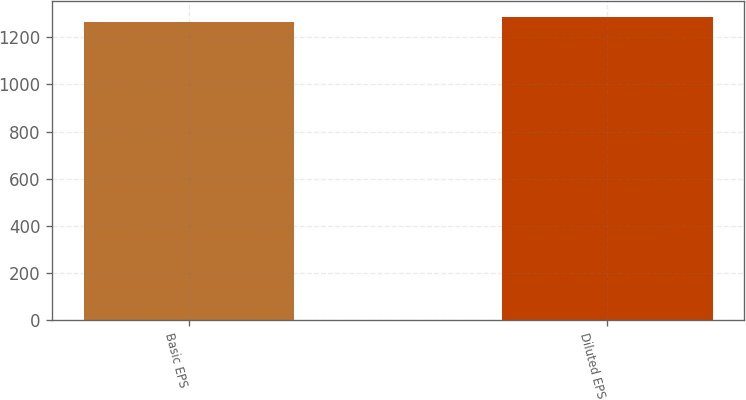Convert chart. <chart><loc_0><loc_0><loc_500><loc_500><bar_chart><fcel>Basic EPS<fcel>Diluted EPS<nl><fcel>1266.4<fcel>1287.9<nl></chart> 